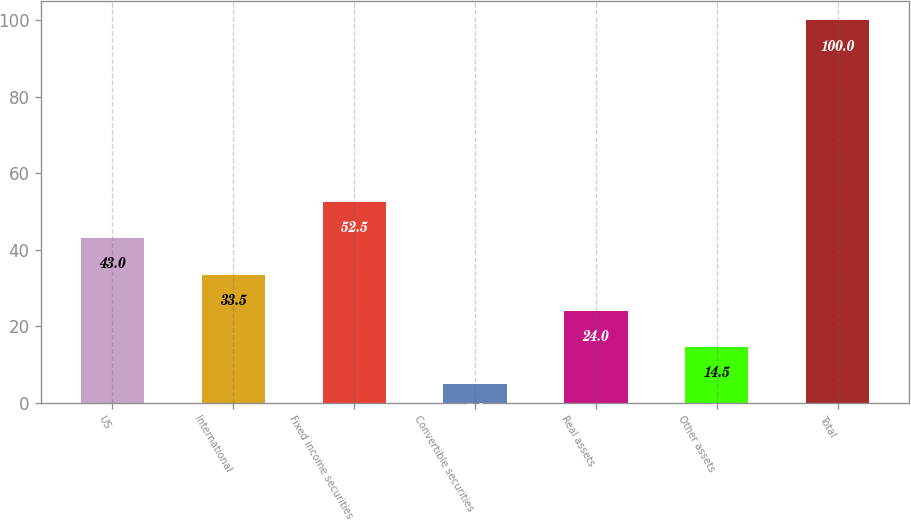Convert chart. <chart><loc_0><loc_0><loc_500><loc_500><bar_chart><fcel>US<fcel>International<fcel>Fixed income securities<fcel>Convertible securities<fcel>Real assets<fcel>Other assets<fcel>Total<nl><fcel>43<fcel>33.5<fcel>52.5<fcel>5<fcel>24<fcel>14.5<fcel>100<nl></chart> 